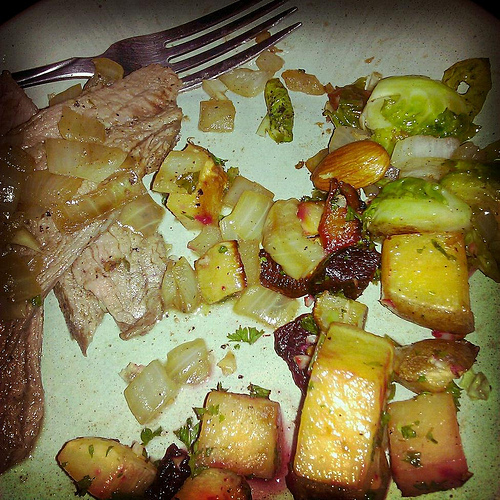<image>
Can you confirm if the food is on the fork? Yes. Looking at the image, I can see the food is positioned on top of the fork, with the fork providing support. 